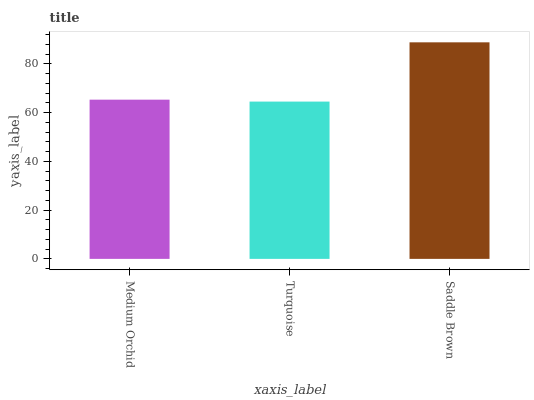Is Turquoise the minimum?
Answer yes or no. Yes. Is Saddle Brown the maximum?
Answer yes or no. Yes. Is Saddle Brown the minimum?
Answer yes or no. No. Is Turquoise the maximum?
Answer yes or no. No. Is Saddle Brown greater than Turquoise?
Answer yes or no. Yes. Is Turquoise less than Saddle Brown?
Answer yes or no. Yes. Is Turquoise greater than Saddle Brown?
Answer yes or no. No. Is Saddle Brown less than Turquoise?
Answer yes or no. No. Is Medium Orchid the high median?
Answer yes or no. Yes. Is Medium Orchid the low median?
Answer yes or no. Yes. Is Turquoise the high median?
Answer yes or no. No. Is Turquoise the low median?
Answer yes or no. No. 